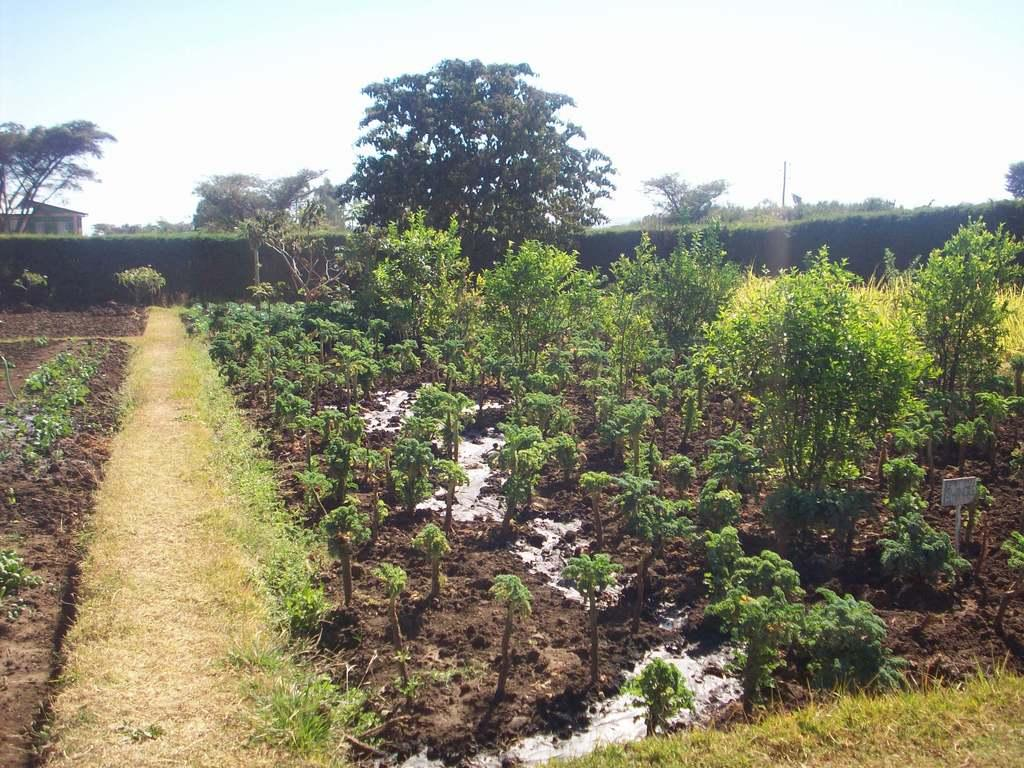What is the main subject in the center of the image? There are plants in the center of the image. What type of vegetation is present in the image? There is grass in the image. What can be seen in the background of the image? There are trees in the background of the image. What is visible at the top of the image? The sky is visible at the top of the image. How many doctors are attempting to treat the plants in the image? There are no doctors present in the image, and the plants do not require treatment. 